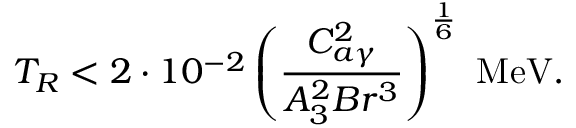<formula> <loc_0><loc_0><loc_500><loc_500>T _ { R } < 2 \cdot 1 0 ^ { - 2 } \left ( \frac { C _ { a \gamma } ^ { 2 } } { A _ { 3 } ^ { 2 } B r ^ { 3 } } \right ) ^ { \frac { 1 } { 6 } } M e V .</formula> 